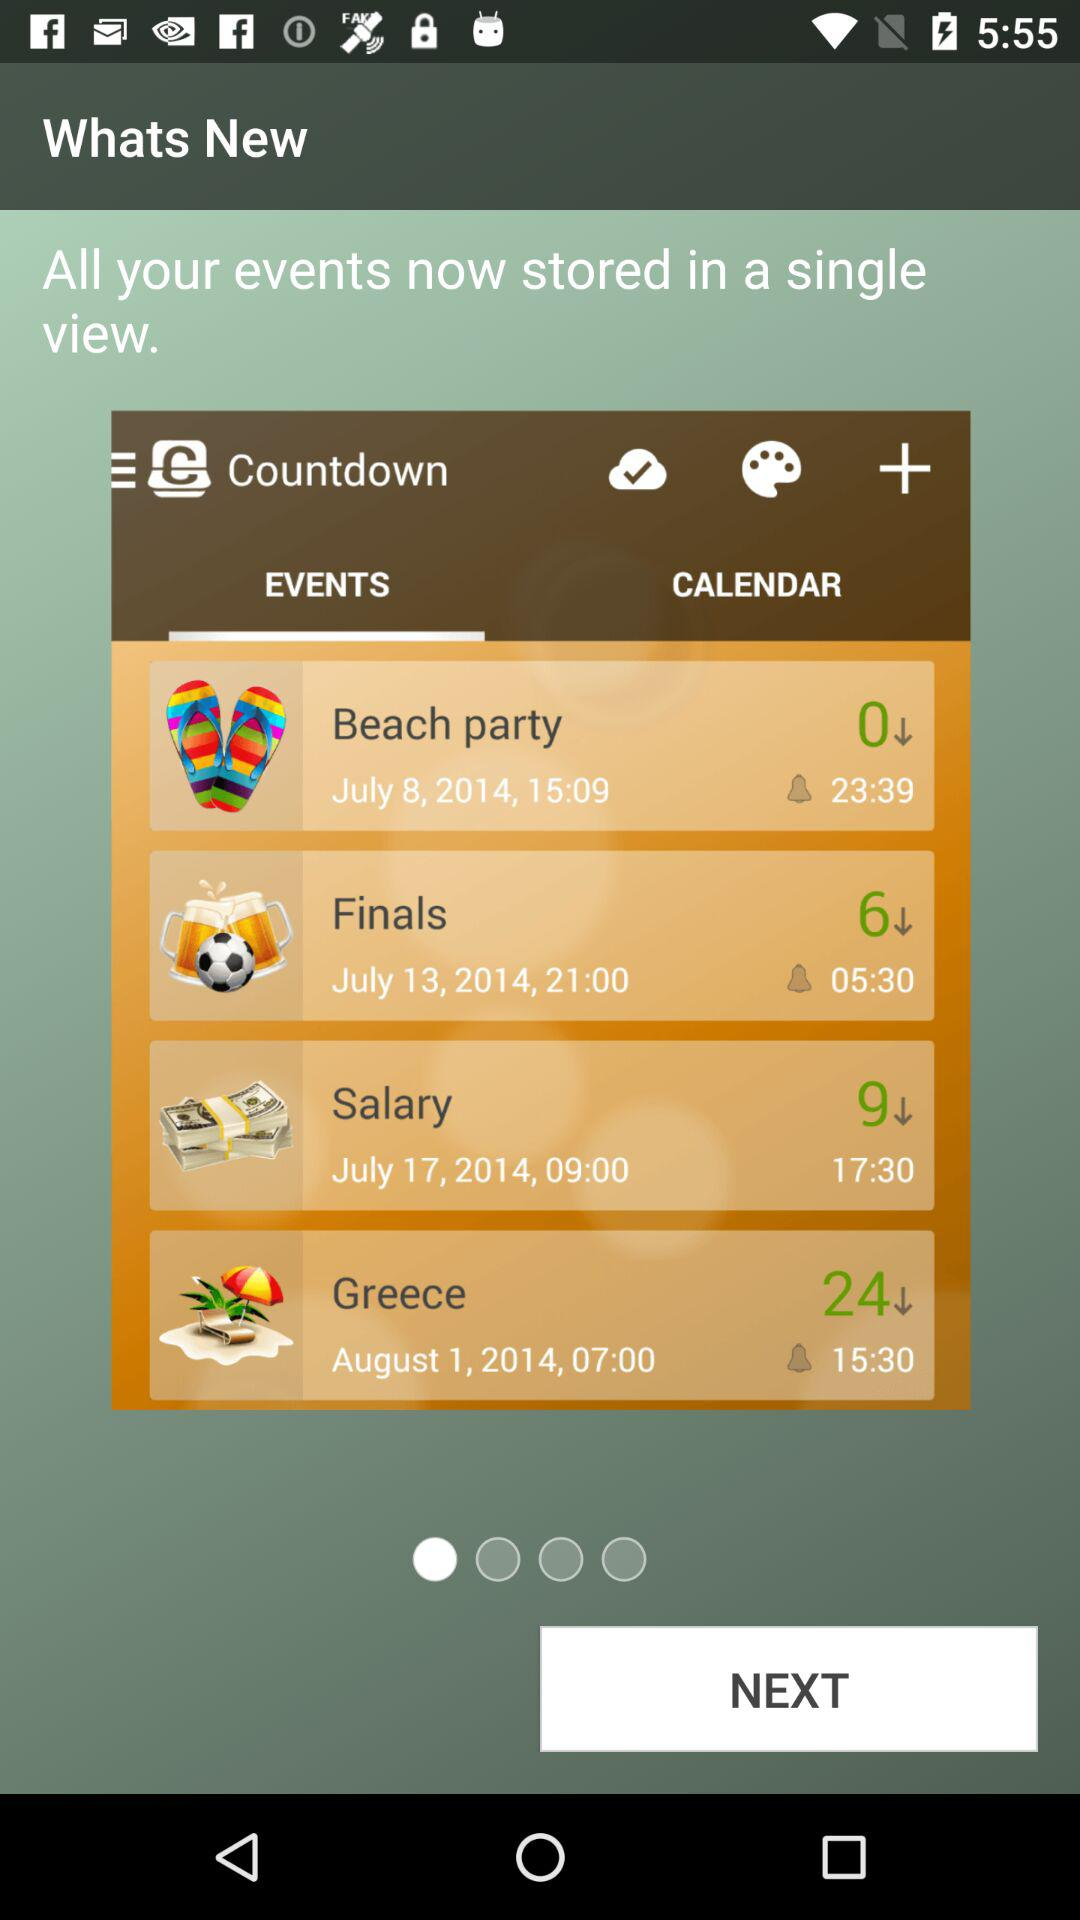Which option is selected? The selected option is "EVENTS". 